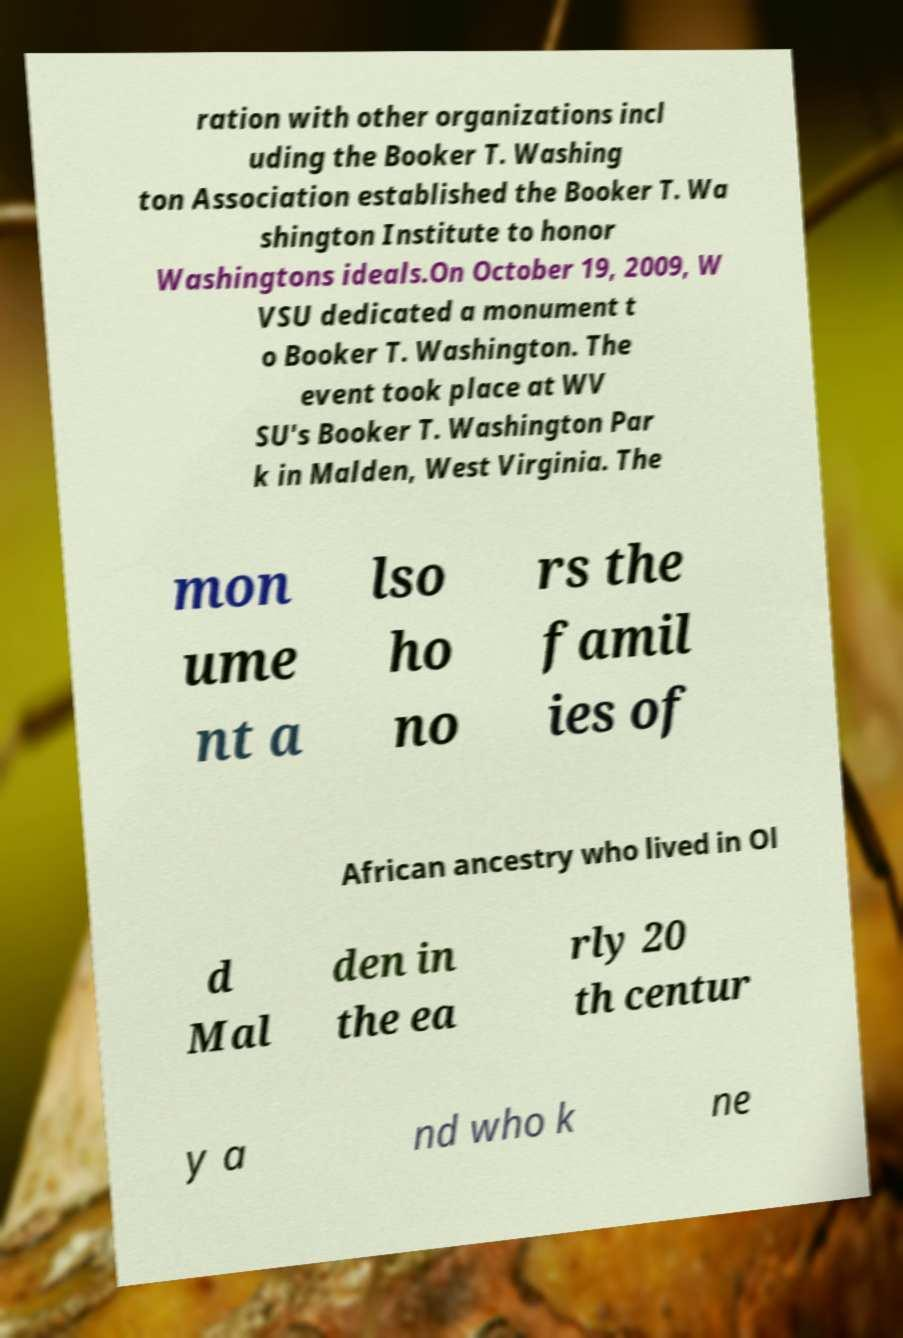Could you extract and type out the text from this image? ration with other organizations incl uding the Booker T. Washing ton Association established the Booker T. Wa shington Institute to honor Washingtons ideals.On October 19, 2009, W VSU dedicated a monument t o Booker T. Washington. The event took place at WV SU's Booker T. Washington Par k in Malden, West Virginia. The mon ume nt a lso ho no rs the famil ies of African ancestry who lived in Ol d Mal den in the ea rly 20 th centur y a nd who k ne 